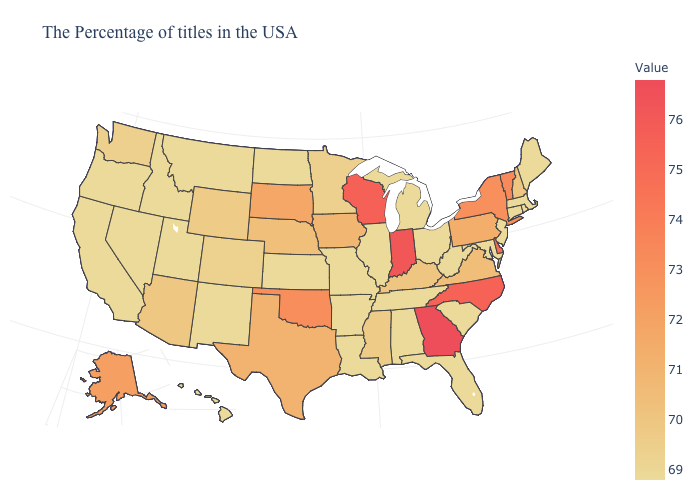Does Florida have a higher value than Kentucky?
Keep it brief. No. Does Washington have a lower value than Nebraska?
Write a very short answer. Yes. Does Pennsylvania have the highest value in the USA?
Be succinct. No. Does Georgia have the highest value in the USA?
Give a very brief answer. Yes. Which states have the lowest value in the USA?
Concise answer only. Maine, Massachusetts, Rhode Island, Connecticut, New Jersey, Maryland, South Carolina, West Virginia, Ohio, Florida, Michigan, Alabama, Tennessee, Illinois, Louisiana, Missouri, Arkansas, Kansas, North Dakota, New Mexico, Utah, Montana, Idaho, Nevada, California, Oregon, Hawaii. 